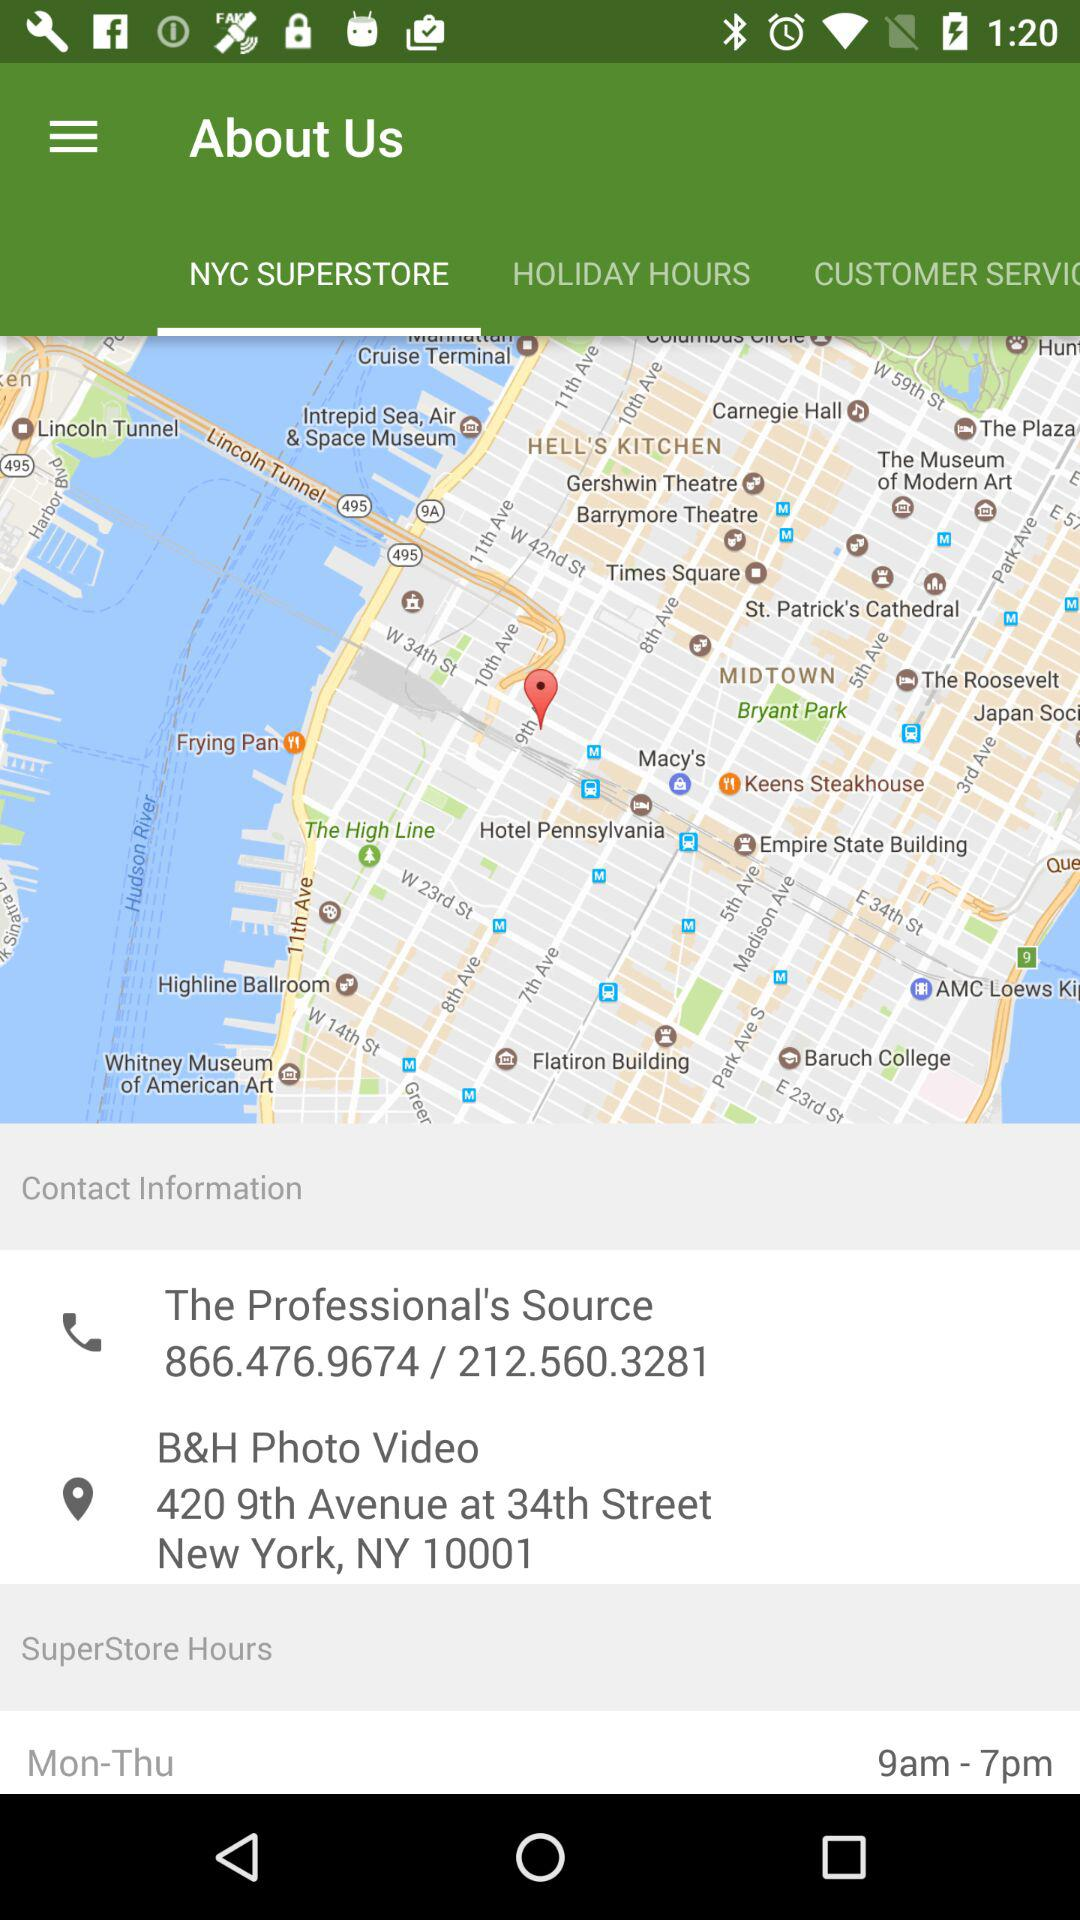Which tab is selected? The selected tab is "NYC SUPERSTORE". 